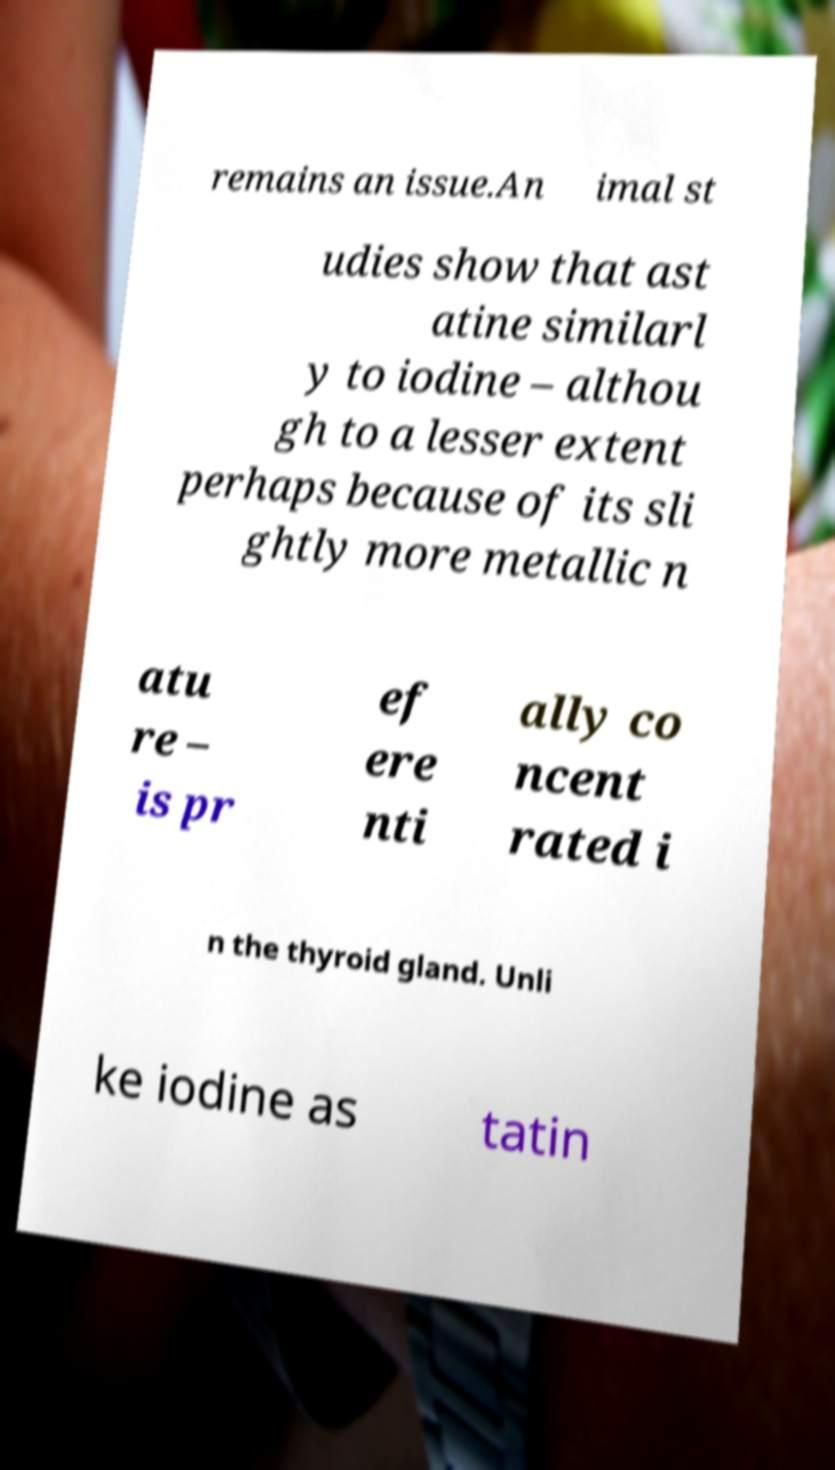Could you extract and type out the text from this image? remains an issue.An imal st udies show that ast atine similarl y to iodine – althou gh to a lesser extent perhaps because of its sli ghtly more metallic n atu re – is pr ef ere nti ally co ncent rated i n the thyroid gland. Unli ke iodine as tatin 